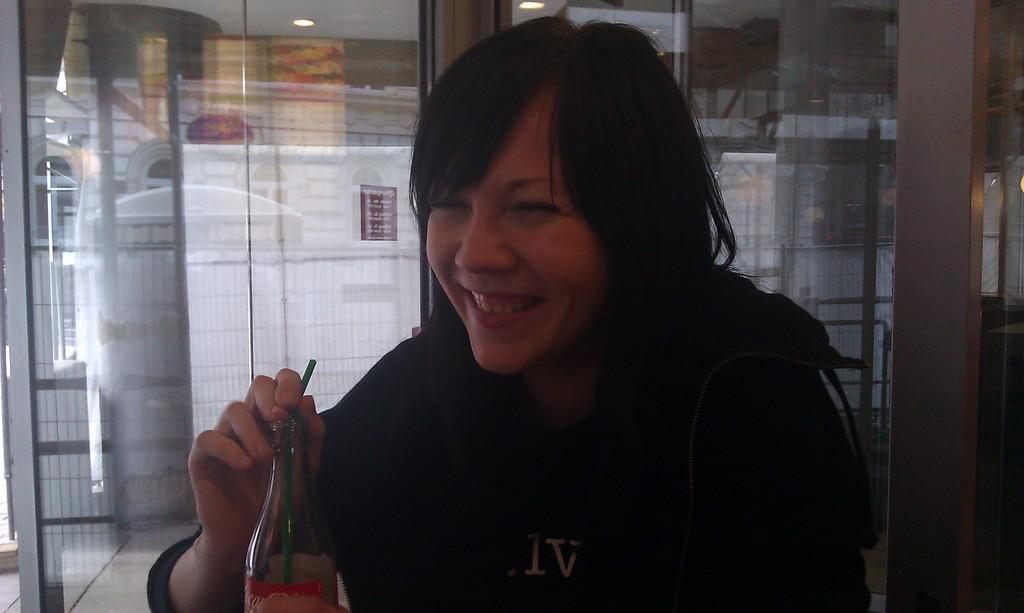What is the person in the image doing? There is a person sitting in the image. What is the person wearing? The person is wearing a black t-shirt. What object is the person holding? The person is holding a glass bottle. What is unique about the glass bottle? The glass bottle has a green straw in it. What type of arch can be seen in the background of the image? There is no arch present in the background of the image. What thought is the person having while sitting in the image? There is no indication of the person's thoughts in the image. 